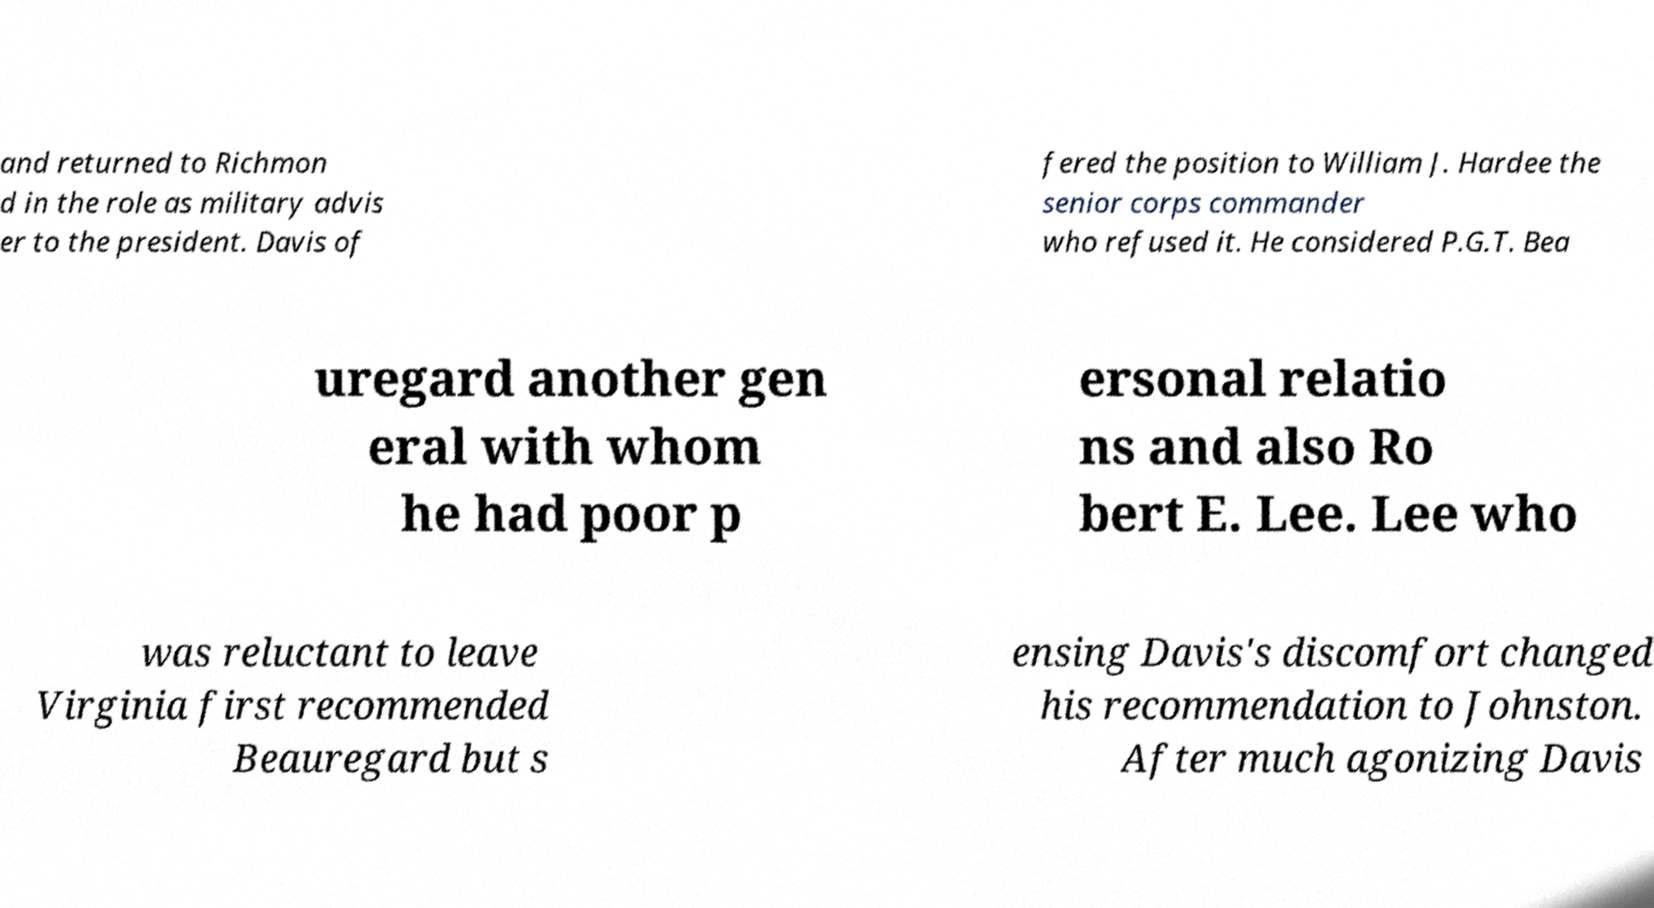I need the written content from this picture converted into text. Can you do that? and returned to Richmon d in the role as military advis er to the president. Davis of fered the position to William J. Hardee the senior corps commander who refused it. He considered P.G.T. Bea uregard another gen eral with whom he had poor p ersonal relatio ns and also Ro bert E. Lee. Lee who was reluctant to leave Virginia first recommended Beauregard but s ensing Davis's discomfort changed his recommendation to Johnston. After much agonizing Davis 